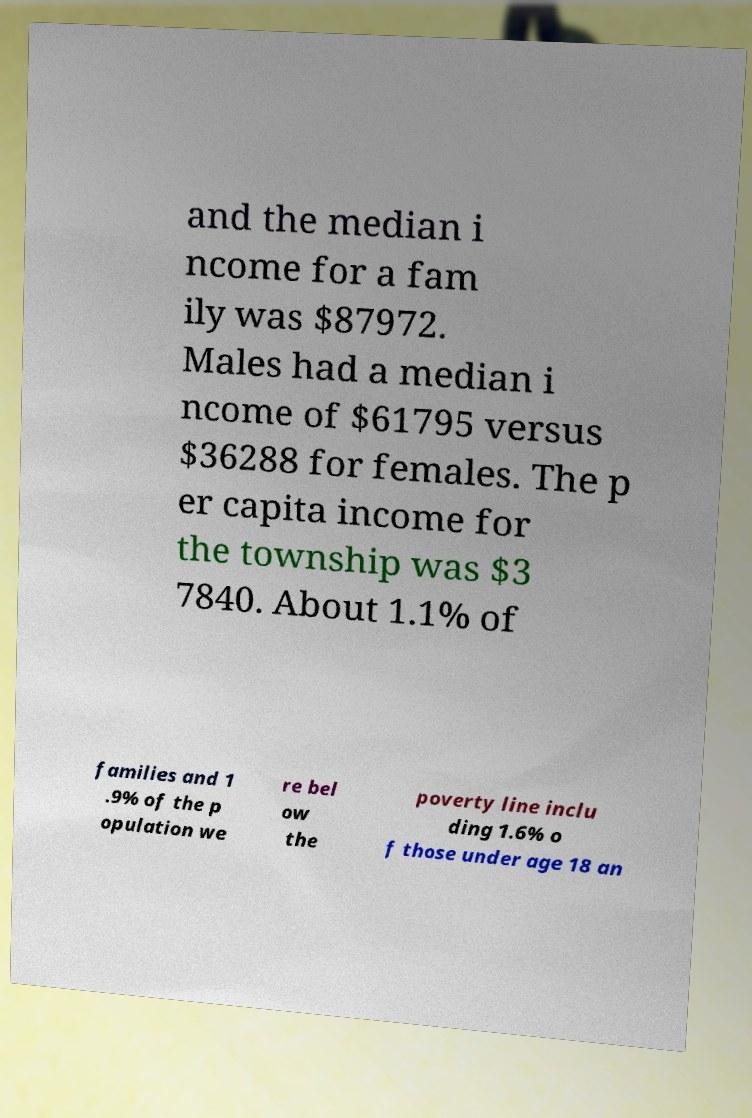Can you read and provide the text displayed in the image?This photo seems to have some interesting text. Can you extract and type it out for me? and the median i ncome for a fam ily was $87972. Males had a median i ncome of $61795 versus $36288 for females. The p er capita income for the township was $3 7840. About 1.1% of families and 1 .9% of the p opulation we re bel ow the poverty line inclu ding 1.6% o f those under age 18 an 